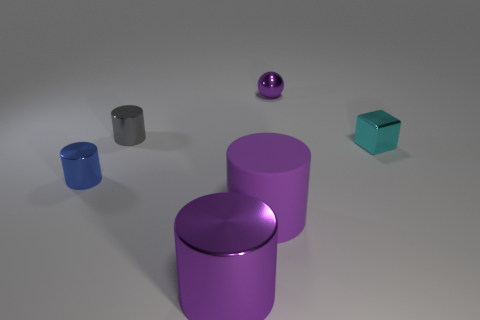Add 4 small cyan objects. How many objects exist? 10 Subtract all balls. How many objects are left? 5 Add 4 small purple objects. How many small purple objects are left? 5 Add 2 gray cylinders. How many gray cylinders exist? 3 Subtract 1 purple cylinders. How many objects are left? 5 Subtract all cyan blocks. Subtract all metallic cylinders. How many objects are left? 2 